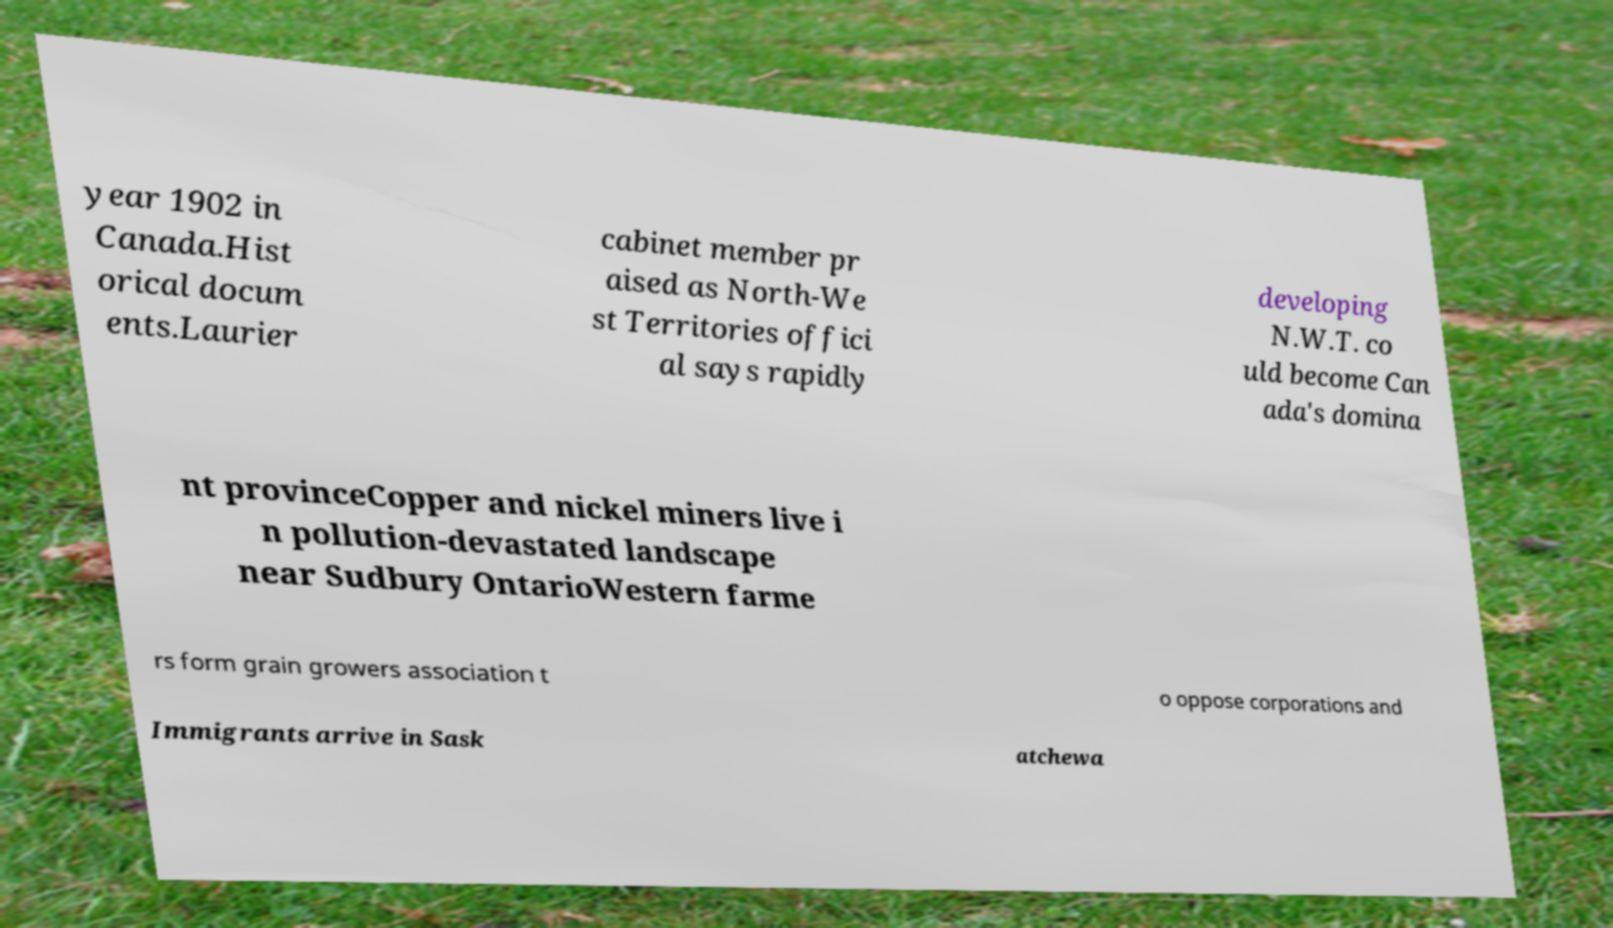Can you read and provide the text displayed in the image?This photo seems to have some interesting text. Can you extract and type it out for me? year 1902 in Canada.Hist orical docum ents.Laurier cabinet member pr aised as North-We st Territories offici al says rapidly developing N.W.T. co uld become Can ada's domina nt provinceCopper and nickel miners live i n pollution-devastated landscape near Sudbury OntarioWestern farme rs form grain growers association t o oppose corporations and Immigrants arrive in Sask atchewa 